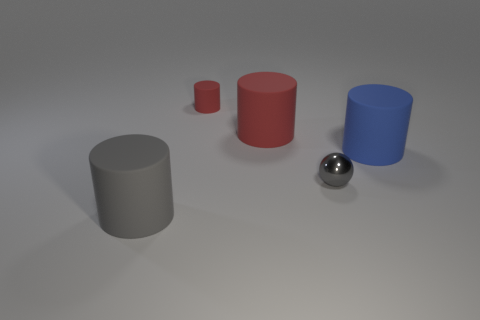Is there any other thing that is the same material as the sphere?
Your response must be concise. No. What number of matte objects are right of the tiny cylinder and behind the blue matte cylinder?
Your answer should be compact. 1. What color is the cylinder that is behind the red rubber object to the right of the tiny red rubber cylinder?
Ensure brevity in your answer.  Red. Are there the same number of blue rubber cylinders to the left of the tiny metallic ball and big cyan shiny objects?
Provide a succinct answer. Yes. How many things are left of the gray object that is behind the big gray matte cylinder that is on the left side of the big blue cylinder?
Offer a very short reply. 3. What is the color of the cylinder that is in front of the sphere?
Provide a succinct answer. Gray. There is a thing that is both to the right of the big red matte thing and left of the blue cylinder; what material is it?
Your answer should be very brief. Metal. There is a gray thing on the left side of the tiny red matte cylinder; how many gray balls are on the right side of it?
Offer a very short reply. 1. What is the shape of the small red object?
Your response must be concise. Cylinder. There is a small red object that is the same material as the gray cylinder; what is its shape?
Offer a very short reply. Cylinder. 